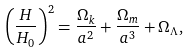Convert formula to latex. <formula><loc_0><loc_0><loc_500><loc_500>\left ( \frac { H } { H _ { 0 } } \right ) ^ { 2 } = \frac { \Omega _ { k } } { a ^ { 2 } } + \frac { \Omega _ { m } } { a ^ { 3 } } + \Omega _ { \Lambda } ,</formula> 